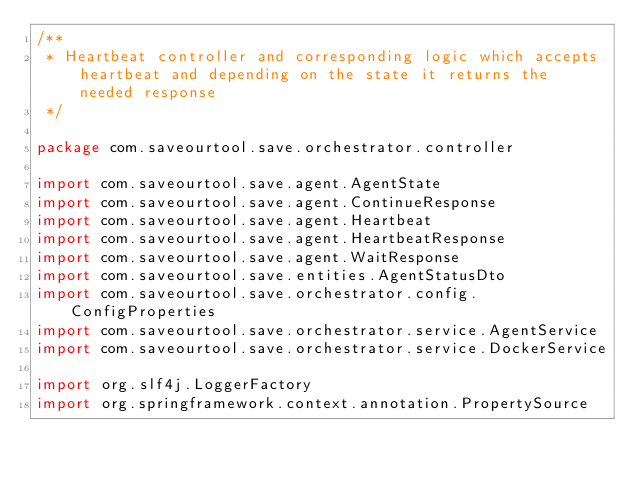Convert code to text. <code><loc_0><loc_0><loc_500><loc_500><_Kotlin_>/**
 * Heartbeat controller and corresponding logic which accepts heartbeat and depending on the state it returns the needed response
 */

package com.saveourtool.save.orchestrator.controller

import com.saveourtool.save.agent.AgentState
import com.saveourtool.save.agent.ContinueResponse
import com.saveourtool.save.agent.Heartbeat
import com.saveourtool.save.agent.HeartbeatResponse
import com.saveourtool.save.agent.WaitResponse
import com.saveourtool.save.entities.AgentStatusDto
import com.saveourtool.save.orchestrator.config.ConfigProperties
import com.saveourtool.save.orchestrator.service.AgentService
import com.saveourtool.save.orchestrator.service.DockerService

import org.slf4j.LoggerFactory
import org.springframework.context.annotation.PropertySource</code> 